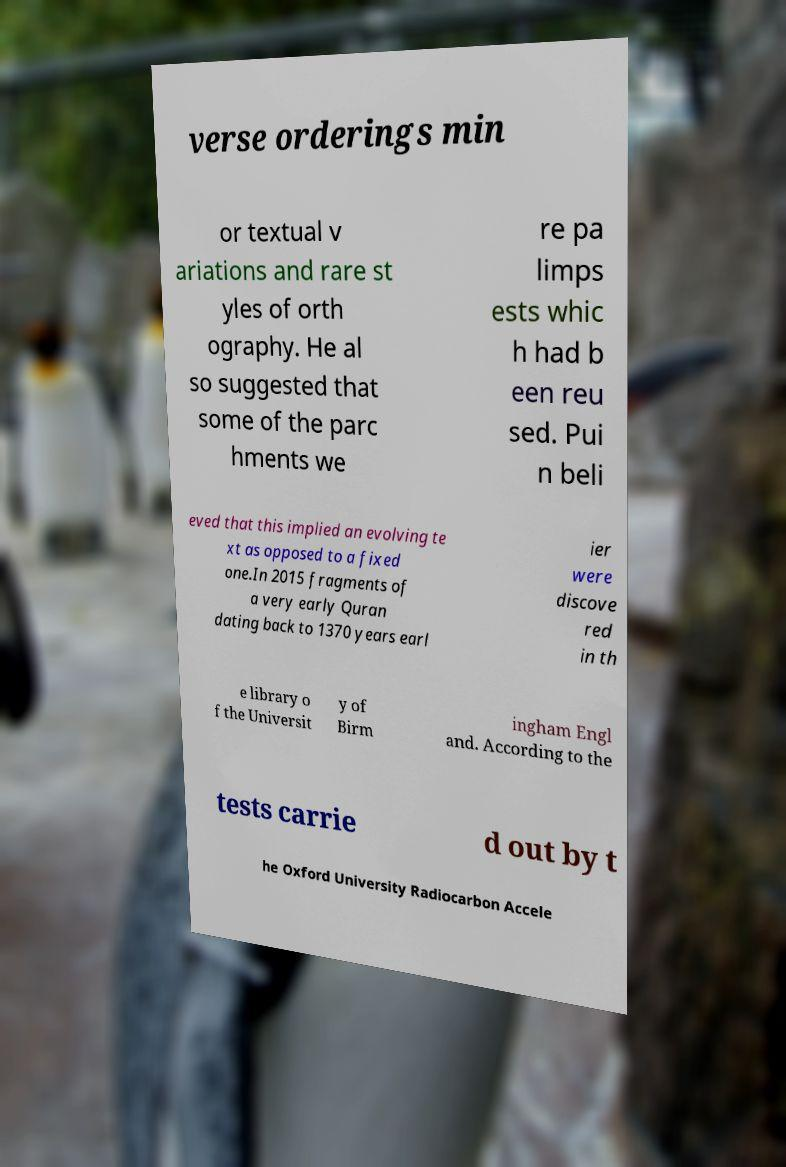I need the written content from this picture converted into text. Can you do that? verse orderings min or textual v ariations and rare st yles of orth ography. He al so suggested that some of the parc hments we re pa limps ests whic h had b een reu sed. Pui n beli eved that this implied an evolving te xt as opposed to a fixed one.In 2015 fragments of a very early Quran dating back to 1370 years earl ier were discove red in th e library o f the Universit y of Birm ingham Engl and. According to the tests carrie d out by t he Oxford University Radiocarbon Accele 